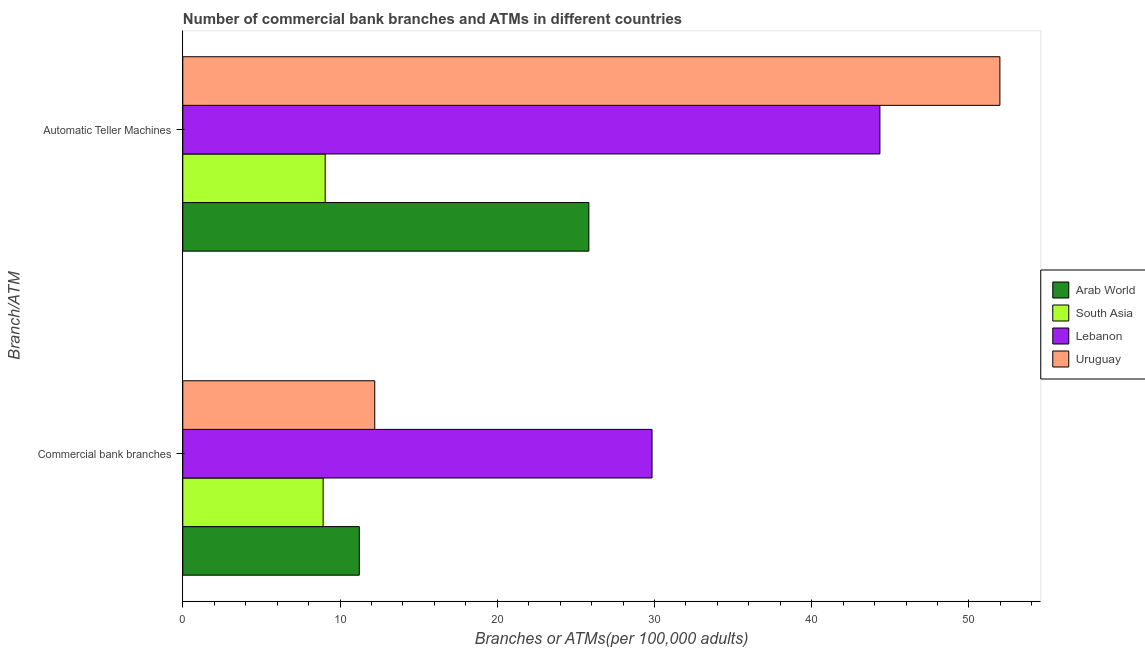How many groups of bars are there?
Keep it short and to the point. 2. Are the number of bars on each tick of the Y-axis equal?
Provide a short and direct response. Yes. How many bars are there on the 2nd tick from the top?
Give a very brief answer. 4. How many bars are there on the 1st tick from the bottom?
Provide a short and direct response. 4. What is the label of the 2nd group of bars from the top?
Your answer should be compact. Commercial bank branches. What is the number of atms in Arab World?
Your response must be concise. 25.83. Across all countries, what is the maximum number of atms?
Your response must be concise. 51.97. Across all countries, what is the minimum number of commercal bank branches?
Offer a terse response. 8.93. In which country was the number of atms maximum?
Your response must be concise. Uruguay. In which country was the number of atms minimum?
Ensure brevity in your answer.  South Asia. What is the total number of commercal bank branches in the graph?
Ensure brevity in your answer.  62.2. What is the difference between the number of commercal bank branches in Uruguay and that in South Asia?
Give a very brief answer. 3.28. What is the difference between the number of commercal bank branches in Uruguay and the number of atms in Lebanon?
Your answer should be compact. -32.13. What is the average number of commercal bank branches per country?
Provide a succinct answer. 15.55. What is the difference between the number of commercal bank branches and number of atms in Arab World?
Keep it short and to the point. -14.6. In how many countries, is the number of atms greater than 42 ?
Keep it short and to the point. 2. What is the ratio of the number of commercal bank branches in Arab World to that in South Asia?
Provide a short and direct response. 1.26. In how many countries, is the number of atms greater than the average number of atms taken over all countries?
Offer a very short reply. 2. What does the 2nd bar from the top in Commercial bank branches represents?
Your answer should be very brief. Lebanon. What does the 3rd bar from the bottom in Automatic Teller Machines represents?
Your response must be concise. Lebanon. Are all the bars in the graph horizontal?
Your answer should be compact. Yes. How many countries are there in the graph?
Keep it short and to the point. 4. What is the difference between two consecutive major ticks on the X-axis?
Make the answer very short. 10. Are the values on the major ticks of X-axis written in scientific E-notation?
Offer a very short reply. No. Does the graph contain any zero values?
Your answer should be compact. No. Does the graph contain grids?
Make the answer very short. No. How are the legend labels stacked?
Ensure brevity in your answer.  Vertical. What is the title of the graph?
Provide a succinct answer. Number of commercial bank branches and ATMs in different countries. What is the label or title of the X-axis?
Make the answer very short. Branches or ATMs(per 100,0 adults). What is the label or title of the Y-axis?
Your response must be concise. Branch/ATM. What is the Branches or ATMs(per 100,000 adults) in Arab World in Commercial bank branches?
Ensure brevity in your answer.  11.23. What is the Branches or ATMs(per 100,000 adults) in South Asia in Commercial bank branches?
Make the answer very short. 8.93. What is the Branches or ATMs(per 100,000 adults) in Lebanon in Commercial bank branches?
Keep it short and to the point. 29.84. What is the Branches or ATMs(per 100,000 adults) in Uruguay in Commercial bank branches?
Provide a succinct answer. 12.21. What is the Branches or ATMs(per 100,000 adults) of Arab World in Automatic Teller Machines?
Your answer should be compact. 25.83. What is the Branches or ATMs(per 100,000 adults) in South Asia in Automatic Teller Machines?
Your response must be concise. 9.06. What is the Branches or ATMs(per 100,000 adults) in Lebanon in Automatic Teller Machines?
Your answer should be very brief. 44.34. What is the Branches or ATMs(per 100,000 adults) in Uruguay in Automatic Teller Machines?
Provide a short and direct response. 51.97. Across all Branch/ATM, what is the maximum Branches or ATMs(per 100,000 adults) in Arab World?
Your response must be concise. 25.83. Across all Branch/ATM, what is the maximum Branches or ATMs(per 100,000 adults) in South Asia?
Keep it short and to the point. 9.06. Across all Branch/ATM, what is the maximum Branches or ATMs(per 100,000 adults) in Lebanon?
Give a very brief answer. 44.34. Across all Branch/ATM, what is the maximum Branches or ATMs(per 100,000 adults) of Uruguay?
Give a very brief answer. 51.97. Across all Branch/ATM, what is the minimum Branches or ATMs(per 100,000 adults) of Arab World?
Make the answer very short. 11.23. Across all Branch/ATM, what is the minimum Branches or ATMs(per 100,000 adults) in South Asia?
Keep it short and to the point. 8.93. Across all Branch/ATM, what is the minimum Branches or ATMs(per 100,000 adults) in Lebanon?
Offer a very short reply. 29.84. Across all Branch/ATM, what is the minimum Branches or ATMs(per 100,000 adults) of Uruguay?
Keep it short and to the point. 12.21. What is the total Branches or ATMs(per 100,000 adults) in Arab World in the graph?
Provide a short and direct response. 37.05. What is the total Branches or ATMs(per 100,000 adults) of South Asia in the graph?
Provide a succinct answer. 17.98. What is the total Branches or ATMs(per 100,000 adults) of Lebanon in the graph?
Provide a succinct answer. 74.18. What is the total Branches or ATMs(per 100,000 adults) of Uruguay in the graph?
Ensure brevity in your answer.  64.18. What is the difference between the Branches or ATMs(per 100,000 adults) of Arab World in Commercial bank branches and that in Automatic Teller Machines?
Give a very brief answer. -14.6. What is the difference between the Branches or ATMs(per 100,000 adults) in South Asia in Commercial bank branches and that in Automatic Teller Machines?
Ensure brevity in your answer.  -0.13. What is the difference between the Branches or ATMs(per 100,000 adults) of Lebanon in Commercial bank branches and that in Automatic Teller Machines?
Offer a very short reply. -14.49. What is the difference between the Branches or ATMs(per 100,000 adults) of Uruguay in Commercial bank branches and that in Automatic Teller Machines?
Provide a succinct answer. -39.76. What is the difference between the Branches or ATMs(per 100,000 adults) in Arab World in Commercial bank branches and the Branches or ATMs(per 100,000 adults) in South Asia in Automatic Teller Machines?
Offer a very short reply. 2.17. What is the difference between the Branches or ATMs(per 100,000 adults) in Arab World in Commercial bank branches and the Branches or ATMs(per 100,000 adults) in Lebanon in Automatic Teller Machines?
Offer a very short reply. -33.11. What is the difference between the Branches or ATMs(per 100,000 adults) in Arab World in Commercial bank branches and the Branches or ATMs(per 100,000 adults) in Uruguay in Automatic Teller Machines?
Provide a succinct answer. -40.74. What is the difference between the Branches or ATMs(per 100,000 adults) of South Asia in Commercial bank branches and the Branches or ATMs(per 100,000 adults) of Lebanon in Automatic Teller Machines?
Give a very brief answer. -35.41. What is the difference between the Branches or ATMs(per 100,000 adults) of South Asia in Commercial bank branches and the Branches or ATMs(per 100,000 adults) of Uruguay in Automatic Teller Machines?
Your answer should be compact. -43.04. What is the difference between the Branches or ATMs(per 100,000 adults) in Lebanon in Commercial bank branches and the Branches or ATMs(per 100,000 adults) in Uruguay in Automatic Teller Machines?
Make the answer very short. -22.12. What is the average Branches or ATMs(per 100,000 adults) of Arab World per Branch/ATM?
Your answer should be very brief. 18.53. What is the average Branches or ATMs(per 100,000 adults) in South Asia per Branch/ATM?
Keep it short and to the point. 8.99. What is the average Branches or ATMs(per 100,000 adults) in Lebanon per Branch/ATM?
Provide a short and direct response. 37.09. What is the average Branches or ATMs(per 100,000 adults) of Uruguay per Branch/ATM?
Offer a very short reply. 32.09. What is the difference between the Branches or ATMs(per 100,000 adults) of Arab World and Branches or ATMs(per 100,000 adults) of South Asia in Commercial bank branches?
Keep it short and to the point. 2.3. What is the difference between the Branches or ATMs(per 100,000 adults) in Arab World and Branches or ATMs(per 100,000 adults) in Lebanon in Commercial bank branches?
Offer a very short reply. -18.62. What is the difference between the Branches or ATMs(per 100,000 adults) in Arab World and Branches or ATMs(per 100,000 adults) in Uruguay in Commercial bank branches?
Make the answer very short. -0.98. What is the difference between the Branches or ATMs(per 100,000 adults) of South Asia and Branches or ATMs(per 100,000 adults) of Lebanon in Commercial bank branches?
Offer a very short reply. -20.92. What is the difference between the Branches or ATMs(per 100,000 adults) of South Asia and Branches or ATMs(per 100,000 adults) of Uruguay in Commercial bank branches?
Ensure brevity in your answer.  -3.28. What is the difference between the Branches or ATMs(per 100,000 adults) in Lebanon and Branches or ATMs(per 100,000 adults) in Uruguay in Commercial bank branches?
Provide a succinct answer. 17.64. What is the difference between the Branches or ATMs(per 100,000 adults) of Arab World and Branches or ATMs(per 100,000 adults) of South Asia in Automatic Teller Machines?
Your answer should be very brief. 16.77. What is the difference between the Branches or ATMs(per 100,000 adults) in Arab World and Branches or ATMs(per 100,000 adults) in Lebanon in Automatic Teller Machines?
Ensure brevity in your answer.  -18.51. What is the difference between the Branches or ATMs(per 100,000 adults) of Arab World and Branches or ATMs(per 100,000 adults) of Uruguay in Automatic Teller Machines?
Make the answer very short. -26.14. What is the difference between the Branches or ATMs(per 100,000 adults) of South Asia and Branches or ATMs(per 100,000 adults) of Lebanon in Automatic Teller Machines?
Your answer should be very brief. -35.28. What is the difference between the Branches or ATMs(per 100,000 adults) in South Asia and Branches or ATMs(per 100,000 adults) in Uruguay in Automatic Teller Machines?
Provide a short and direct response. -42.91. What is the difference between the Branches or ATMs(per 100,000 adults) in Lebanon and Branches or ATMs(per 100,000 adults) in Uruguay in Automatic Teller Machines?
Offer a very short reply. -7.63. What is the ratio of the Branches or ATMs(per 100,000 adults) in Arab World in Commercial bank branches to that in Automatic Teller Machines?
Offer a terse response. 0.43. What is the ratio of the Branches or ATMs(per 100,000 adults) of South Asia in Commercial bank branches to that in Automatic Teller Machines?
Your answer should be very brief. 0.99. What is the ratio of the Branches or ATMs(per 100,000 adults) of Lebanon in Commercial bank branches to that in Automatic Teller Machines?
Keep it short and to the point. 0.67. What is the ratio of the Branches or ATMs(per 100,000 adults) in Uruguay in Commercial bank branches to that in Automatic Teller Machines?
Offer a very short reply. 0.23. What is the difference between the highest and the second highest Branches or ATMs(per 100,000 adults) in Arab World?
Ensure brevity in your answer.  14.6. What is the difference between the highest and the second highest Branches or ATMs(per 100,000 adults) of South Asia?
Offer a terse response. 0.13. What is the difference between the highest and the second highest Branches or ATMs(per 100,000 adults) in Lebanon?
Your response must be concise. 14.49. What is the difference between the highest and the second highest Branches or ATMs(per 100,000 adults) in Uruguay?
Provide a succinct answer. 39.76. What is the difference between the highest and the lowest Branches or ATMs(per 100,000 adults) in Arab World?
Your answer should be very brief. 14.6. What is the difference between the highest and the lowest Branches or ATMs(per 100,000 adults) of South Asia?
Offer a terse response. 0.13. What is the difference between the highest and the lowest Branches or ATMs(per 100,000 adults) of Lebanon?
Give a very brief answer. 14.49. What is the difference between the highest and the lowest Branches or ATMs(per 100,000 adults) of Uruguay?
Keep it short and to the point. 39.76. 